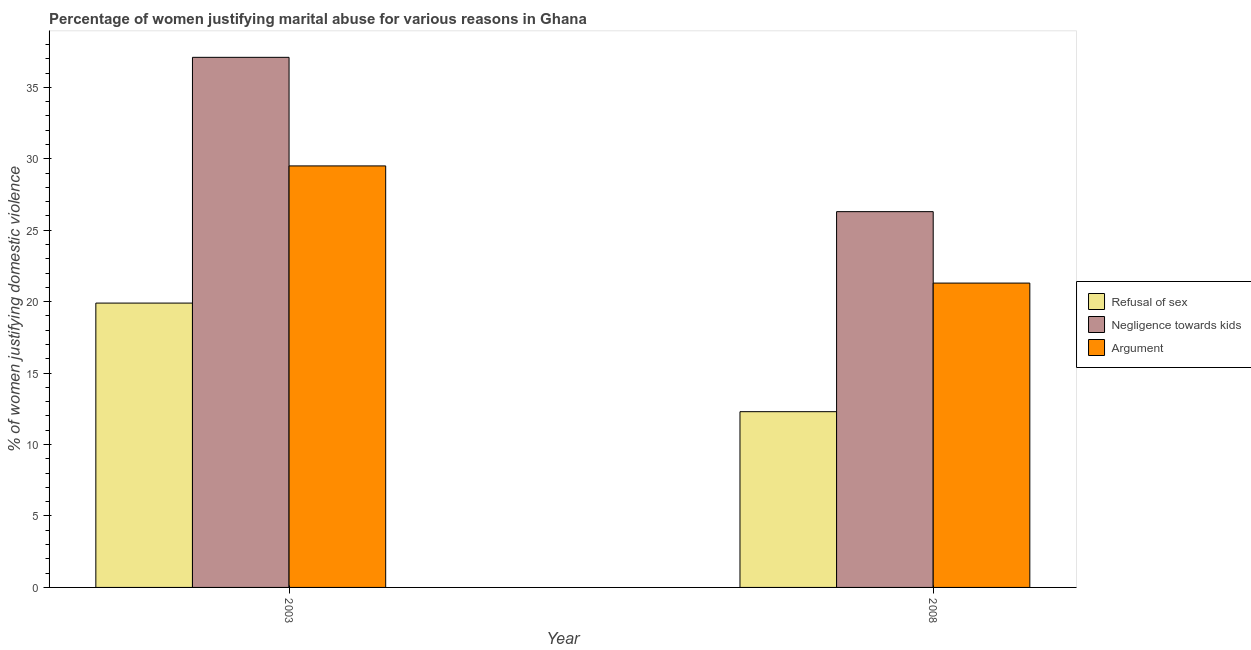How many different coloured bars are there?
Offer a terse response. 3. What is the percentage of women justifying domestic violence due to arguments in 2003?
Provide a short and direct response. 29.5. Across all years, what is the maximum percentage of women justifying domestic violence due to arguments?
Your answer should be compact. 29.5. Across all years, what is the minimum percentage of women justifying domestic violence due to arguments?
Give a very brief answer. 21.3. In which year was the percentage of women justifying domestic violence due to arguments maximum?
Provide a succinct answer. 2003. In which year was the percentage of women justifying domestic violence due to arguments minimum?
Your answer should be compact. 2008. What is the total percentage of women justifying domestic violence due to refusal of sex in the graph?
Offer a terse response. 32.2. What is the difference between the percentage of women justifying domestic violence due to negligence towards kids in 2003 and that in 2008?
Ensure brevity in your answer.  10.8. What is the difference between the percentage of women justifying domestic violence due to negligence towards kids in 2003 and the percentage of women justifying domestic violence due to arguments in 2008?
Give a very brief answer. 10.8. What is the average percentage of women justifying domestic violence due to negligence towards kids per year?
Your answer should be very brief. 31.7. In the year 2003, what is the difference between the percentage of women justifying domestic violence due to negligence towards kids and percentage of women justifying domestic violence due to arguments?
Your response must be concise. 0. In how many years, is the percentage of women justifying domestic violence due to refusal of sex greater than 10 %?
Make the answer very short. 2. What is the ratio of the percentage of women justifying domestic violence due to arguments in 2003 to that in 2008?
Offer a very short reply. 1.38. What does the 1st bar from the left in 2003 represents?
Your response must be concise. Refusal of sex. What does the 3rd bar from the right in 2003 represents?
Ensure brevity in your answer.  Refusal of sex. Is it the case that in every year, the sum of the percentage of women justifying domestic violence due to refusal of sex and percentage of women justifying domestic violence due to negligence towards kids is greater than the percentage of women justifying domestic violence due to arguments?
Ensure brevity in your answer.  Yes. Are all the bars in the graph horizontal?
Offer a very short reply. No. Does the graph contain any zero values?
Ensure brevity in your answer.  No. What is the title of the graph?
Offer a terse response. Percentage of women justifying marital abuse for various reasons in Ghana. Does "Textiles and clothing" appear as one of the legend labels in the graph?
Provide a succinct answer. No. What is the label or title of the Y-axis?
Ensure brevity in your answer.  % of women justifying domestic violence. What is the % of women justifying domestic violence in Refusal of sex in 2003?
Ensure brevity in your answer.  19.9. What is the % of women justifying domestic violence in Negligence towards kids in 2003?
Offer a very short reply. 37.1. What is the % of women justifying domestic violence of Argument in 2003?
Make the answer very short. 29.5. What is the % of women justifying domestic violence of Negligence towards kids in 2008?
Your answer should be compact. 26.3. What is the % of women justifying domestic violence of Argument in 2008?
Your answer should be very brief. 21.3. Across all years, what is the maximum % of women justifying domestic violence in Refusal of sex?
Your answer should be very brief. 19.9. Across all years, what is the maximum % of women justifying domestic violence of Negligence towards kids?
Your response must be concise. 37.1. Across all years, what is the maximum % of women justifying domestic violence in Argument?
Offer a terse response. 29.5. Across all years, what is the minimum % of women justifying domestic violence in Refusal of sex?
Offer a terse response. 12.3. Across all years, what is the minimum % of women justifying domestic violence in Negligence towards kids?
Offer a terse response. 26.3. Across all years, what is the minimum % of women justifying domestic violence in Argument?
Keep it short and to the point. 21.3. What is the total % of women justifying domestic violence in Refusal of sex in the graph?
Offer a very short reply. 32.2. What is the total % of women justifying domestic violence in Negligence towards kids in the graph?
Offer a terse response. 63.4. What is the total % of women justifying domestic violence in Argument in the graph?
Make the answer very short. 50.8. What is the difference between the % of women justifying domestic violence of Refusal of sex in 2003 and that in 2008?
Give a very brief answer. 7.6. What is the difference between the % of women justifying domestic violence in Argument in 2003 and that in 2008?
Provide a short and direct response. 8.2. What is the difference between the % of women justifying domestic violence in Negligence towards kids in 2003 and the % of women justifying domestic violence in Argument in 2008?
Keep it short and to the point. 15.8. What is the average % of women justifying domestic violence in Refusal of sex per year?
Keep it short and to the point. 16.1. What is the average % of women justifying domestic violence of Negligence towards kids per year?
Provide a succinct answer. 31.7. What is the average % of women justifying domestic violence of Argument per year?
Your answer should be very brief. 25.4. In the year 2003, what is the difference between the % of women justifying domestic violence of Refusal of sex and % of women justifying domestic violence of Negligence towards kids?
Your response must be concise. -17.2. In the year 2003, what is the difference between the % of women justifying domestic violence in Refusal of sex and % of women justifying domestic violence in Argument?
Offer a terse response. -9.6. In the year 2003, what is the difference between the % of women justifying domestic violence of Negligence towards kids and % of women justifying domestic violence of Argument?
Provide a succinct answer. 7.6. In the year 2008, what is the difference between the % of women justifying domestic violence of Refusal of sex and % of women justifying domestic violence of Negligence towards kids?
Your answer should be very brief. -14. In the year 2008, what is the difference between the % of women justifying domestic violence of Refusal of sex and % of women justifying domestic violence of Argument?
Offer a very short reply. -9. What is the ratio of the % of women justifying domestic violence in Refusal of sex in 2003 to that in 2008?
Your answer should be very brief. 1.62. What is the ratio of the % of women justifying domestic violence in Negligence towards kids in 2003 to that in 2008?
Keep it short and to the point. 1.41. What is the ratio of the % of women justifying domestic violence in Argument in 2003 to that in 2008?
Provide a short and direct response. 1.39. What is the difference between the highest and the second highest % of women justifying domestic violence of Argument?
Keep it short and to the point. 8.2. What is the difference between the highest and the lowest % of women justifying domestic violence of Negligence towards kids?
Your answer should be very brief. 10.8. 